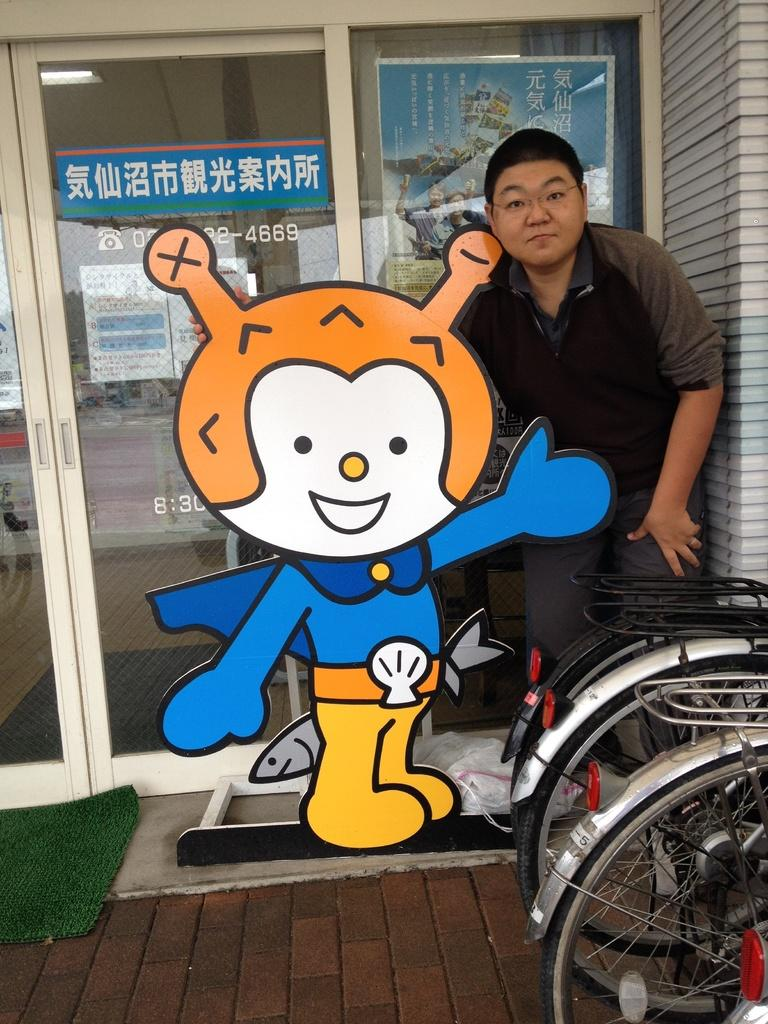Who or what is present in the image? There is a person in the image. What is the person doing or standing near? The person is standing beside a toy. Are there any vehicles or transportation-related objects in the image? There are two bicycles in the right corner of the image. What type of barrier or entrance can be seen behind the person? There is a glass door behind the person. What type of animal is visible in the image? There is no animal present in the image. Is the person's father also visible in the image? The provided facts do not mention the person's father, so we cannot determine if they are present in the image. 